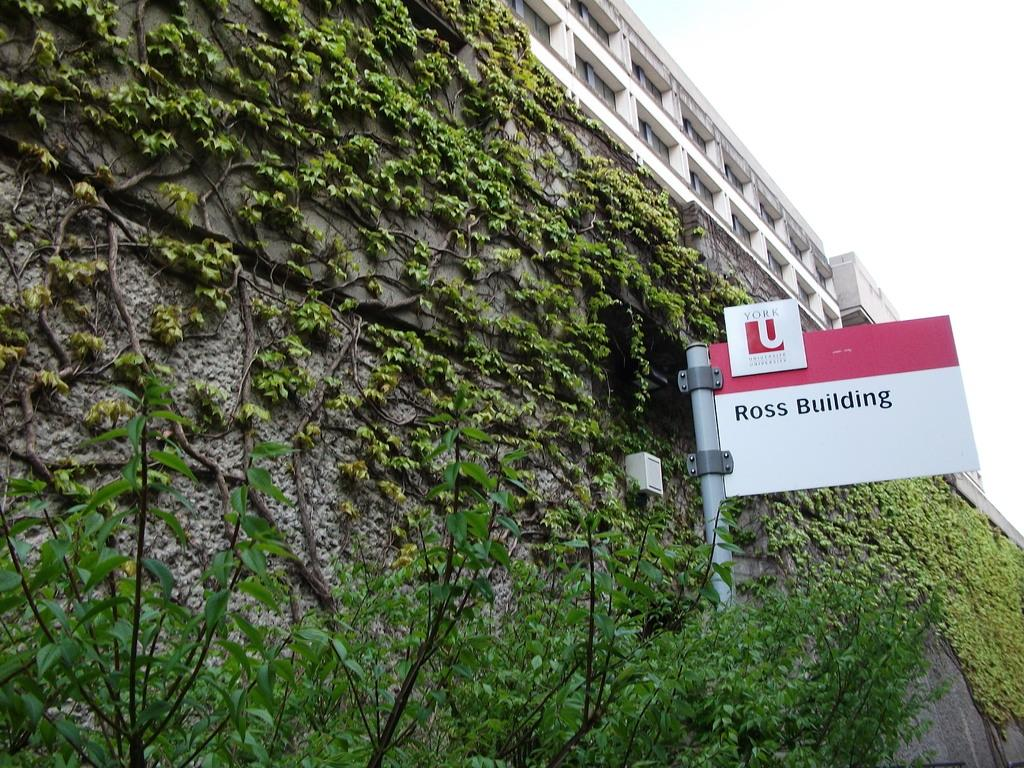What type of living organisms can be seen in the image? Plants are visible in the image. What is the primary structure in the image? There is a wall in the image. What object can be found in the image that is typically used for storage? There is a box in the image. What is attached to the pole in the image? There is a board attached to the pole in the image. What is located on the right side of the image? There is a building, a wall, and glass windows on the right side of the image. What part of the natural environment is visible in the image? The sky is visible in the image. How many beads are present on the wall in the image? There are no beads present on the wall in the image. What type of patch is visible on the building in the image? There is no patch visible on the building in the image. 